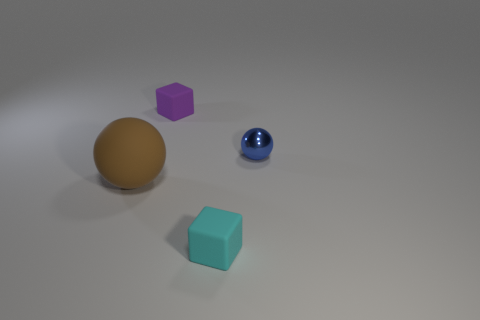Add 4 big gray rubber spheres. How many objects exist? 8 Add 2 small red things. How many small red things exist? 2 Subtract 0 green blocks. How many objects are left? 4 Subtract all small blue spheres. Subtract all green rubber spheres. How many objects are left? 3 Add 1 tiny blue balls. How many tiny blue balls are left? 2 